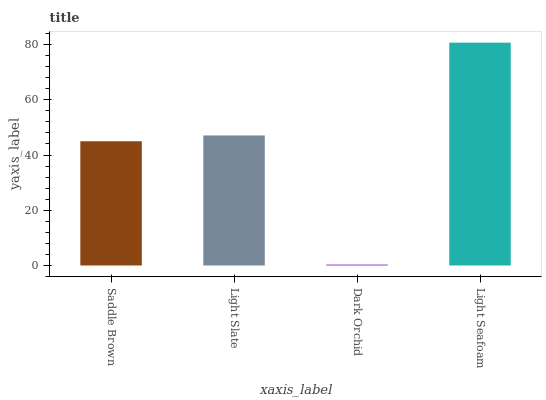Is Dark Orchid the minimum?
Answer yes or no. Yes. Is Light Seafoam the maximum?
Answer yes or no. Yes. Is Light Slate the minimum?
Answer yes or no. No. Is Light Slate the maximum?
Answer yes or no. No. Is Light Slate greater than Saddle Brown?
Answer yes or no. Yes. Is Saddle Brown less than Light Slate?
Answer yes or no. Yes. Is Saddle Brown greater than Light Slate?
Answer yes or no. No. Is Light Slate less than Saddle Brown?
Answer yes or no. No. Is Light Slate the high median?
Answer yes or no. Yes. Is Saddle Brown the low median?
Answer yes or no. Yes. Is Light Seafoam the high median?
Answer yes or no. No. Is Light Seafoam the low median?
Answer yes or no. No. 